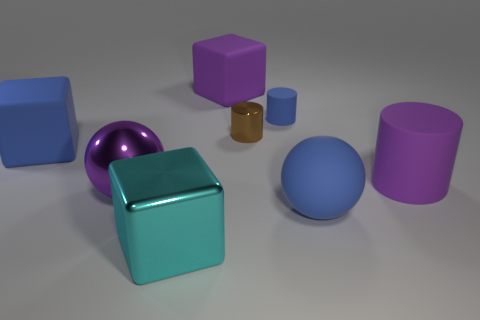Do the small matte thing and the rubber ball have the same color?
Make the answer very short. Yes. What material is the sphere that is the same color as the large cylinder?
Your answer should be compact. Metal. The large block that is made of the same material as the tiny brown cylinder is what color?
Provide a short and direct response. Cyan. How many objects are either cylinders that are to the right of the purple metallic ball or blocks that are on the left side of the cyan shiny block?
Keep it short and to the point. 4. Does the blue thing that is on the left side of the brown metallic thing have the same size as the metal object behind the large purple shiny object?
Your answer should be compact. No. The other metallic thing that is the same shape as the tiny blue thing is what color?
Make the answer very short. Brown. Is the number of blue things that are behind the purple cylinder greater than the number of cylinders that are behind the big purple cube?
Your answer should be very brief. Yes. How big is the matte cylinder that is on the left side of the large blue object that is in front of the matte block that is in front of the tiny metal thing?
Make the answer very short. Small. Does the tiny blue object have the same material as the large blue object that is on the left side of the small shiny cylinder?
Provide a succinct answer. Yes. Is the shape of the brown shiny thing the same as the tiny rubber thing?
Give a very brief answer. Yes. 